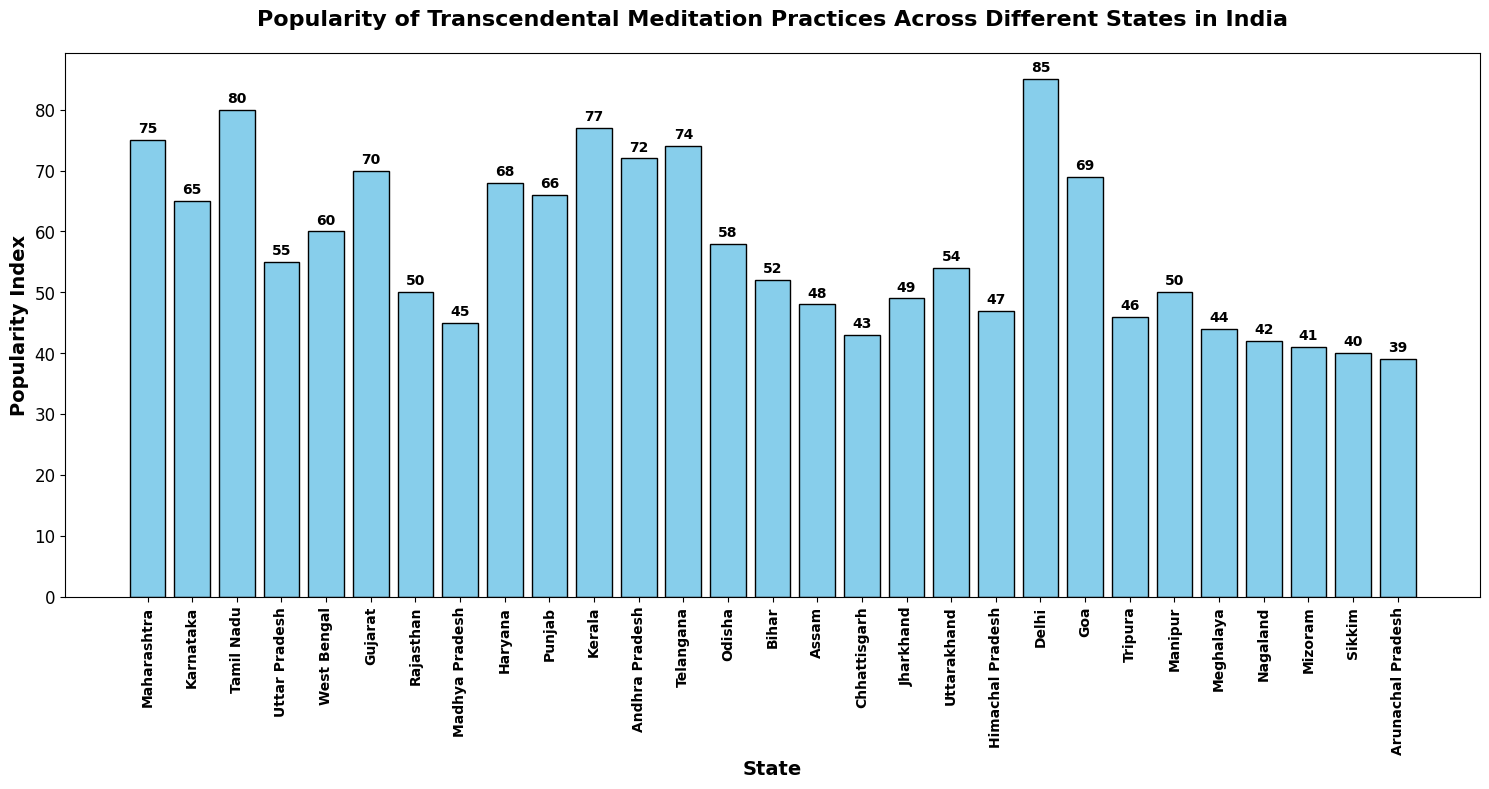What is the most popular Transcendental Meditation practice in terms of the state listed in the bar chart? The bar chart shows that Delhi has the highest popularity index of 85, which makes it the most popular state for Transcendental Meditation practices.
Answer: Delhi Which state has a higher popularity index, Karnataka or Gujarat? By looking at the bar chart, we see that Karnataka has a popularity index of 65, while Gujarat has a slightly higher popularity index of 70.
Answer: Gujarat What is the average popularity index of Maharashtra, Tamil Nadu, and Kerala? The popularity indices of Maharashtra (75), Tamil Nadu (80), and Kerala (77) sum up to 232. Dividing this sum by 3 gives an average popularity index of approximately 77.33.
Answer: 77.33 Which state has the lowest popularity index, and what is its value? The bar chart shows that Arunachal Pradesh has the lowest popularity index, with a value of 39.
Answer: Arunachal Pradesh, 39 What is the difference between the popularity indices of the two most popular states? The two most popular states are Delhi (85) and Tamil Nadu (80). The difference in their popularity indices is 85 - 80 = 5.
Answer: 5 How many states have a popularity index greater than 60? Observing the bar chart, the states with popularity indices greater than 60 are Maharashtra, Karnataka, Tamil Nadu, Gujarat, Haryana, Punjab, Kerala, Andhra Pradesh, Telangana, Delhi, and Goa. Counting these states gives a total of 11 states.
Answer: 11 Which states have a similar popularity index of around 50? By looking at the bar chart, the states with similar popularity indices around 50 are Rajasthan (50), Manipur (50), Bihar (52), and Uttarakhand (54).
Answer: Rajasthan, Manipur, Bihar, Uttarakhand What is the combined popularity index for the states of Haryana, Punjab, and Goa? The popularity indices for Haryana (68), Punjab (66), and Goa (69) sum up to 68 + 66 + 69 = 203.
Answer: 203 What is the range of the popularity index values in the figure? The highest popularity index is 85 (Delhi) and the lowest is 39 (Arunachal Pradesh). The range is calculated by subtracting the lowest from the highest: 85 - 39 = 46.
Answer: 46 What is the median popularity index of all the states listed? To find the median, we first list all the popularity indices in ascending order: 39, 40, 41, 42, 43, 44, 45, 46, 47, 48, 49, 50, 50, 52, 54, 55, 58, 60, 65, 66, 68, 69, 70, 72, 74, 75, 77, 80, 85. The middle value in this 29-element list is the 15th value, which is 54.
Answer: 54 